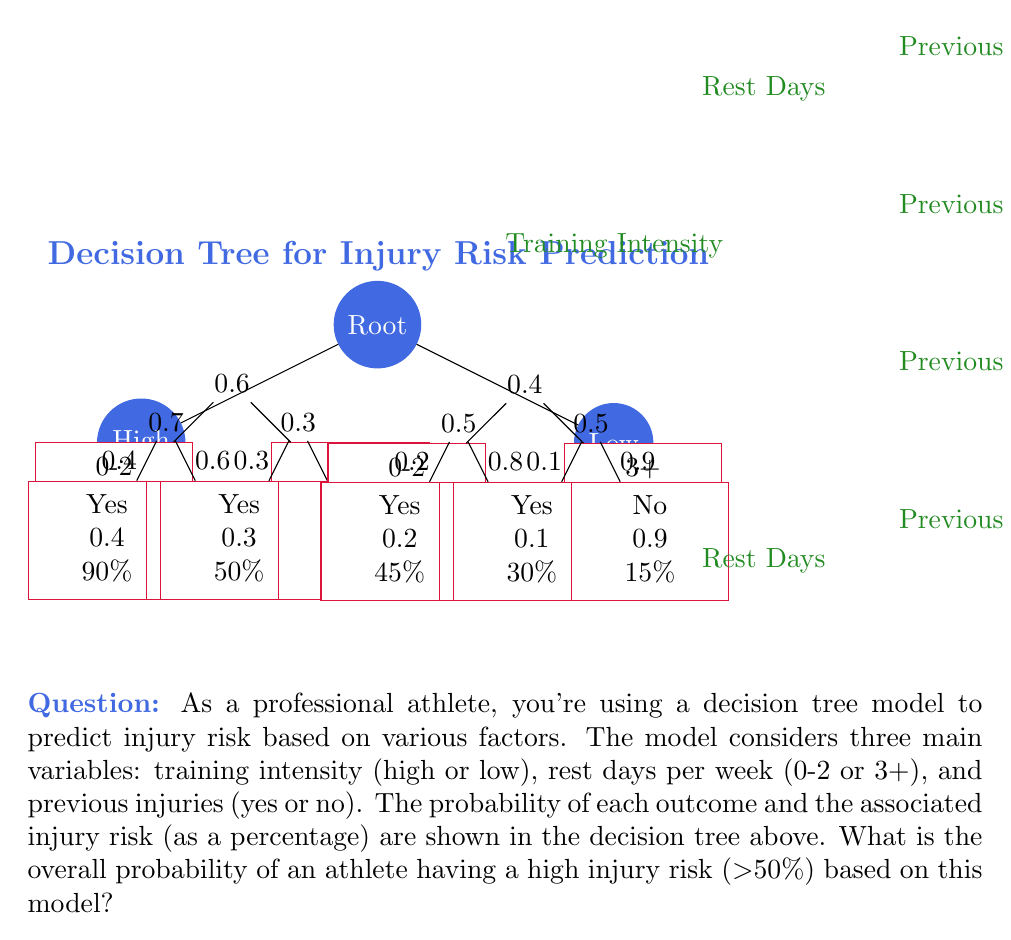Can you answer this question? To solve this problem, we need to calculate the probability of each path leading to a high injury risk (>50%) and sum these probabilities. Let's break it down step-by-step:

1. Identify high-risk paths:
   - High intensity, 0-2 rest days, Previous injuries: 90% risk
   - High intensity, 0-2 rest days, No previous injuries: 60% risk
   - High intensity, 3+ rest days, Previous injuries: 50% risk

2. Calculate the probability of each high-risk path:
   a) P(High, 0-2, Yes) = 0.6 × 0.7 × 0.4 = 0.168
   b) P(High, 0-2, No) = 0.6 × 0.7 × 0.6 = 0.252
   c) P(High, 3+, Yes) = 0.6 × 0.3 × 0.3 = 0.054

3. Sum the probabilities of high-risk paths:
   Total probability = 0.168 + 0.252 + 0.054 = 0.474

4. Convert to percentage:
   0.474 × 100% = 47.4%

Therefore, the overall probability of an athlete having a high injury risk (>50%) based on this model is 47.4%.
Answer: 47.4% 